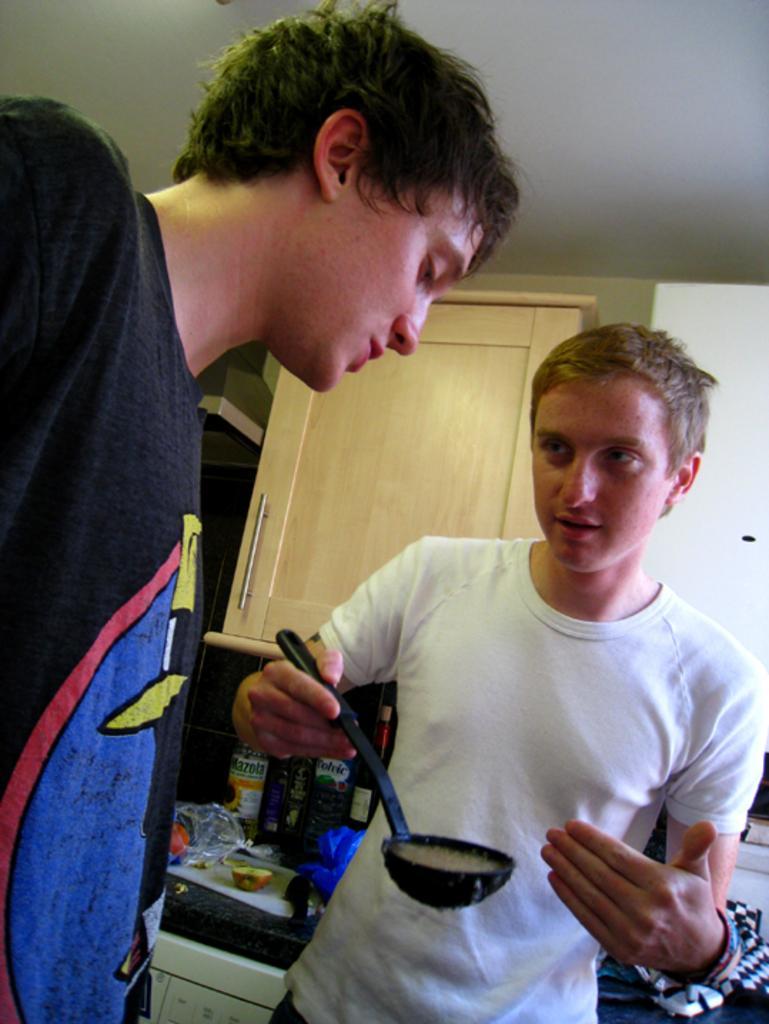Can you describe this image briefly? In the image I can see two men are standing among them the man on the right side is holding an object in the hand. In the background I can see wooden cupboard, a kitchen table which has some objects on it and ceiling. 